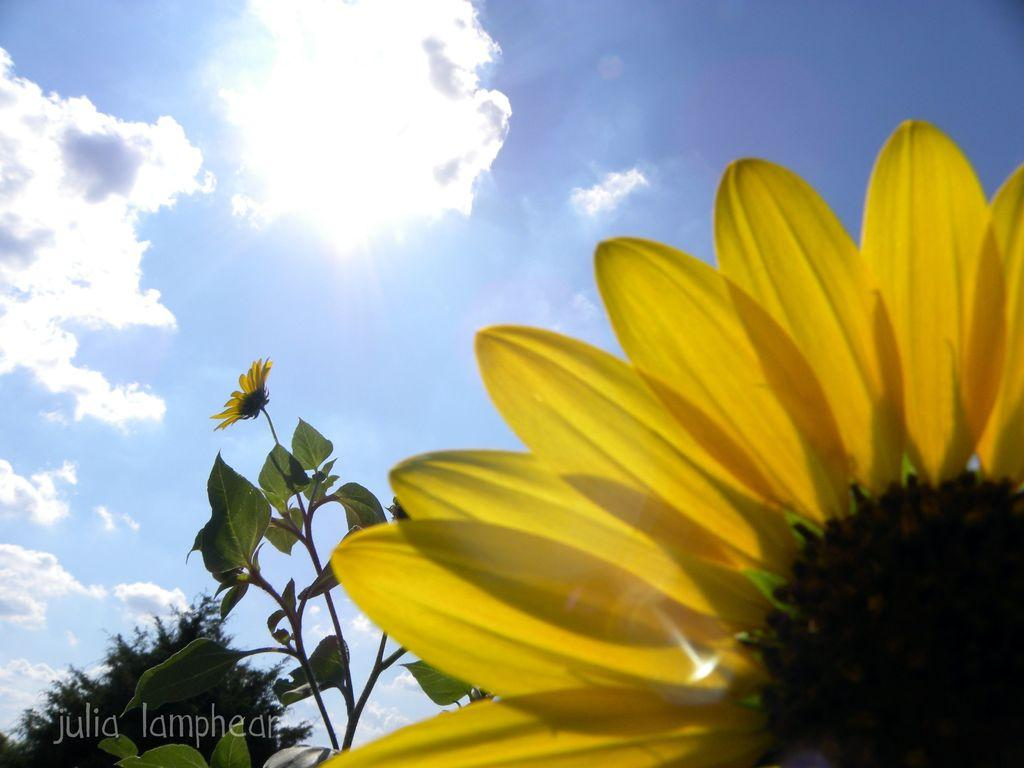What is the main subject in the front of the image? There is a sunflower in the front of the image. What else can be seen related to the sunflower? There is a sunflower plant in the image. What is located at the back of the image? There is a tree at the back of the image. What is visible at the top of the image? The sky is visible at the top of the image. How many pickles are hanging from the sunflower in the image? There are no pickles present in the image; it features a sunflower and a sunflower plant. What type of scale is used to weigh the tree in the image? There is no scale present in the image, and the tree is not being weighed. 